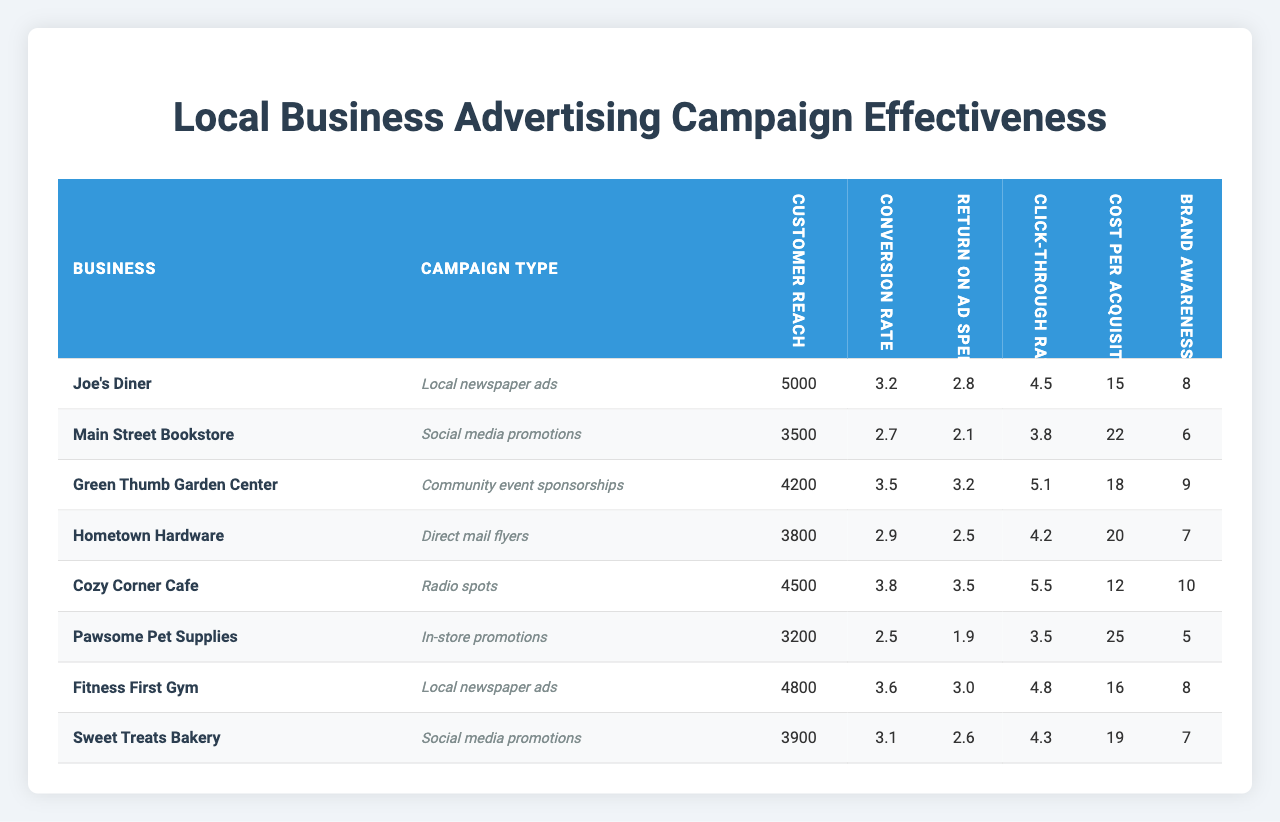What is the Customer Reach for Joe's Diner? The table shows that Joe's Diner has a Customer Reach of 5000.
Answer: 5000 Which business has the highest Return on Ad Spend? Upon analyzing the Return on Ad Spend values, Joe's Diner has the highest value at 2.8.
Answer: Joe's Diner What is the average Cost per Acquisition across all businesses? To find the average Cost per Acquisition, sum all the values (15 + 22 + 18 + 20 + 12 + 25 + 16 + 19) = 147, then divide by 8 businesses, which gives 147 / 8 = 18.375.
Answer: 18.375 Is the Conversion Rate for Sweet Treats Bakery above 3? The Conversion Rate for Sweet Treats Bakery is 3.1, which is indeed above 3.
Answer: Yes What is the difference in Click-Through Rate between Green Thumb Garden Center and Cozy Corner Cafe? The Click-Through Rate for Green Thumb Garden Center is 5.1, while for Cozy Corner Cafe it is 5.5. The difference is 5.5 - 5.1 = 0.4.
Answer: 0.4 Which business has the lowest Brand Awareness Lift and what is that value? Looking at the Brand Awareness Lift column, Pawsome Pet Supplies has the lowest value of 5.
Answer: Pawsome Pet Supplies, 5 What is the sum of Customer Reach for businesses using Direct Mail Flyers and Social Media Promotions? The businesses using Direct Mail Flyers (Cozy Corner Cafe with 4500) and Social Media Promotions (Main Street Bookstore with 3500) have a total Customer Reach of 4500 + 3500 = 8000.
Answer: 8000 Are the Conversion Rates for Fitness First Gym and Hometown Hardware equal? The table indicates that Fitness First Gym has a Conversion Rate of 3.6 and Hometown Hardware has a Conversion Rate of 2.9. These are not equal.
Answer: No What is the average Click-Through Rate for businesses with Customer Reach greater than 4000? The businesses with Customer Reach above 4000 are Joe's Diner (4.5), Green Thumb Garden Center (5.1), Fitness First Gym (4.8), and Cozy Corner Cafe (5.5). Summing these gives 4.5 + 5.1 + 4.8 + 5.5 = 20.9. Dividing by 4 gives an average of 20.9 / 4 = 5.225.
Answer: 5.225 Which advertising campaign type has the highest average Return on Ad Spend? The average Return on Ad Spend for each campaign type is calculated as follows: Local newspaper ads (2.8), Social media promotions (2.1), Community event sponsorships (3.2), Direct mail flyers (2.5), Radio spots (3.5), In-store promotions (1.9). The highest average returns from Community event sponsorships (3.2).
Answer: Community event sponsorships, 3.2 